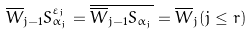Convert formula to latex. <formula><loc_0><loc_0><loc_500><loc_500>\overline { W } _ { j - 1 } S ^ { \varepsilon _ { j } } _ { \alpha _ { j } } = \overline { \overline { W } _ { j - 1 } S _ { \alpha _ { j } } } = \overline { W } _ { j } ( j \leq r )</formula> 